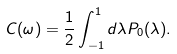<formula> <loc_0><loc_0><loc_500><loc_500>C ( \omega ) = \frac { 1 } { 2 } \int _ { - 1 } ^ { 1 } d \lambda P _ { 0 } ( \lambda ) .</formula> 